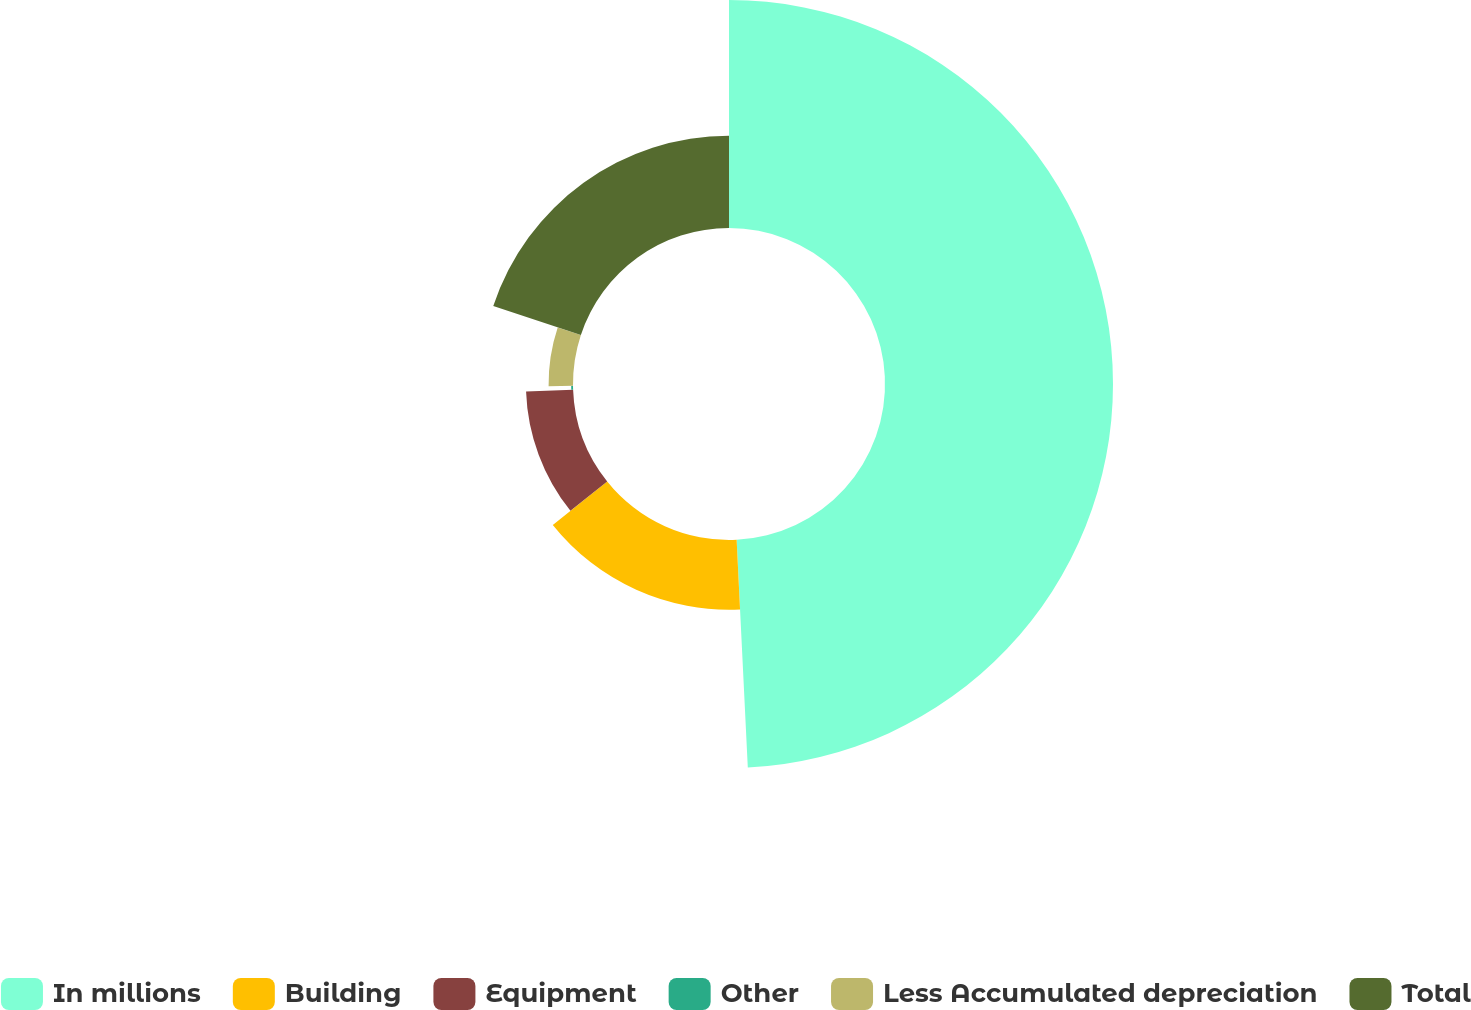Convert chart to OTSL. <chart><loc_0><loc_0><loc_500><loc_500><pie_chart><fcel>In millions<fcel>Building<fcel>Equipment<fcel>Other<fcel>Less Accumulated depreciation<fcel>Total<nl><fcel>49.22%<fcel>15.04%<fcel>10.16%<fcel>0.39%<fcel>5.27%<fcel>19.92%<nl></chart> 